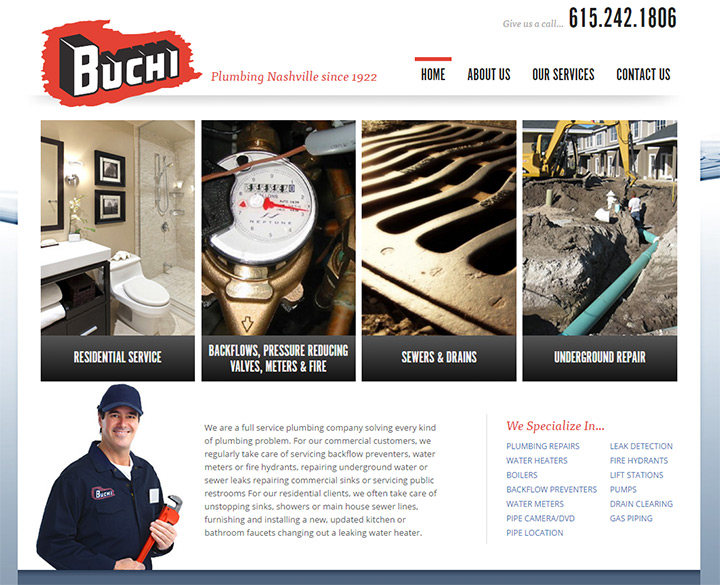Imagine the company has a mascot that appears throughout the site. Describe the mascot and its interactions with users. The company's mascot, 'Plumbo,' is a friendly and knowledgeable plumber depicted in a cartoonish yet professional style. Plumbo wears a hard hat and a tool belt, often seen smiling and engaging with the website's features. As users navigate through the site, Plumbo pops up in various sections, offering tips on plumbing maintenance, explaining services, and even providing fun facts about the company's history. On the 'Contact Us' page, Plumbo is shown holding a smartphone, signifying easy and modern communication methods with the company. The mascot adds a personable and approachable element to the site, enhancing user engagement and making the experience more interactive and enjoyable.  Based on the website design, create a scenario where a user interacts with the website to book a plumbing service. Upon landing on the homepage, a user is instantly drawn to the clean and organized layout. They quickly spot the prominent 'Our Services' section and click through to read more about the range of plumbing solutions offered. Impressed by the detailed descriptions and high-quality images, the user decides that they need a residential plumbing service. They head to the 'Contact Us' page where Plumbo, the friendly mascot, guides them on the various ways to get in touch. The user fills out an easy-to-use booking form, specifying their plumbing issue and preferred date and time. Within moments of submission, they receive a confirmation email with further details about their appointment. The user feels confident and reassured by the seamless experience and the professional presentation of information on the website.  Can you give a short summary of how effectively the website communicates its services? The website effectively communicates its services through a clean, intuitive design, high-quality visuals, and clear, concise content. Key services are prominently displayed, making it easy for users to understand the scope of work offered. The use of a navigation bar and easy-to-find contact information ensures a seamless experience, fostering trust and reliability for both new and returning customers. 